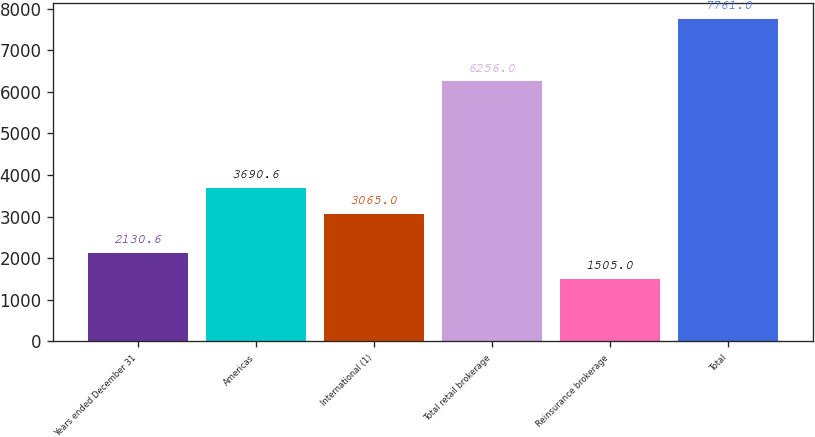<chart> <loc_0><loc_0><loc_500><loc_500><bar_chart><fcel>Years ended December 31<fcel>Americas<fcel>International (1)<fcel>Total retail brokerage<fcel>Reinsurance brokerage<fcel>Total<nl><fcel>2130.6<fcel>3690.6<fcel>3065<fcel>6256<fcel>1505<fcel>7761<nl></chart> 